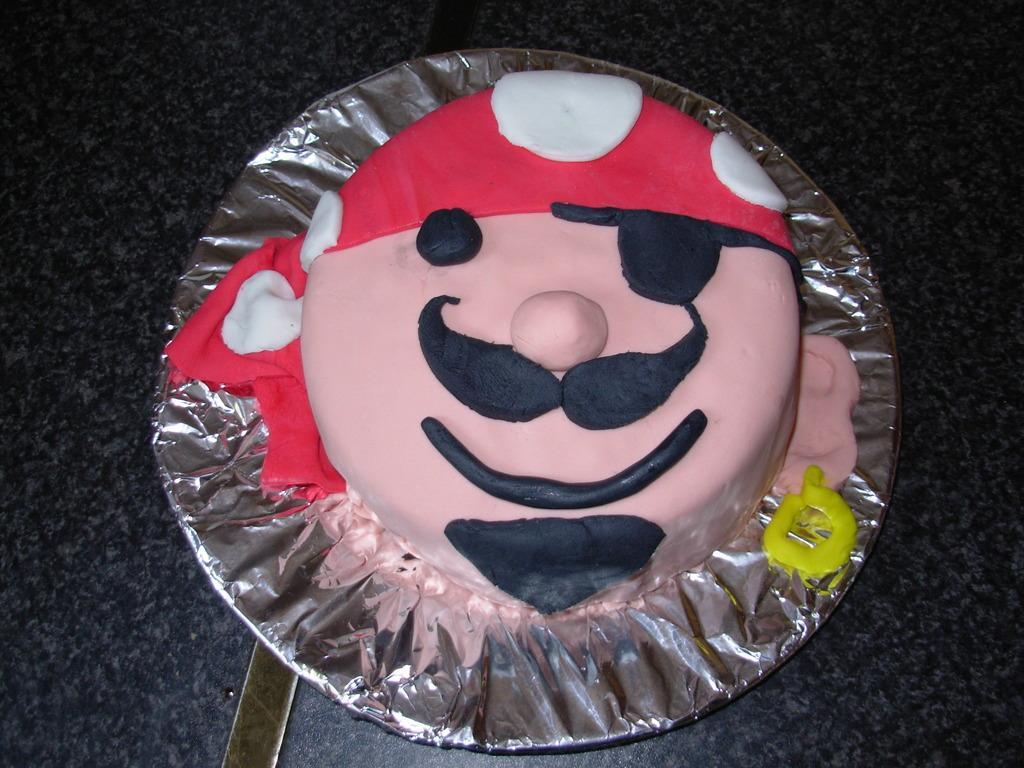In one or two sentences, can you explain what this image depicts? In this image, this looks like a cake, which is placed on the plate. This looks like a silver foil paper. I think this is a table. 